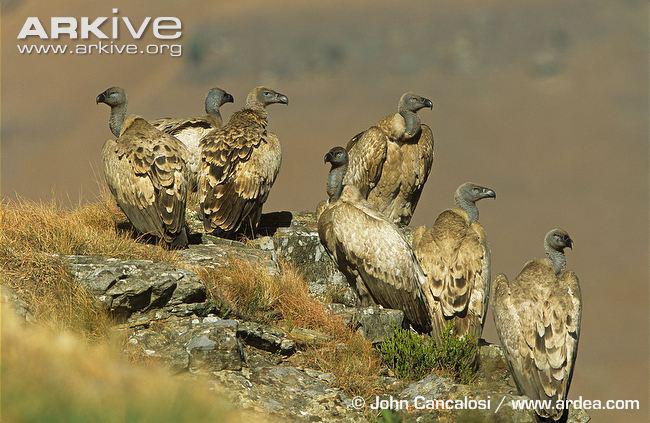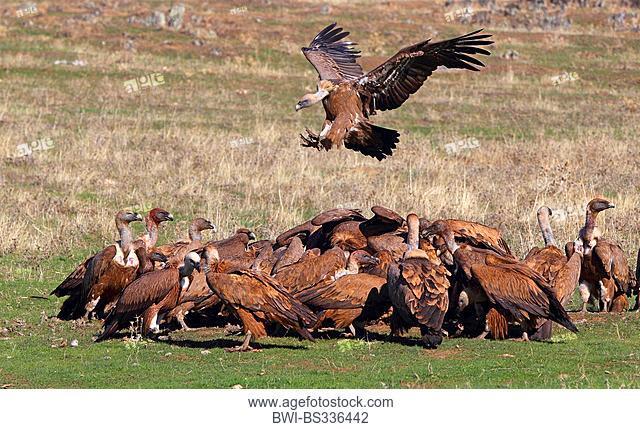The first image is the image on the left, the second image is the image on the right. Given the left and right images, does the statement "Birds are sitting on tree branches in both images." hold true? Answer yes or no. No. The first image is the image on the left, the second image is the image on the right. Given the left and right images, does the statement "One image shows exactly two vultures in a nest of sticks and leaves, and the other image shows several vultures perched on leafless branches." hold true? Answer yes or no. No. 